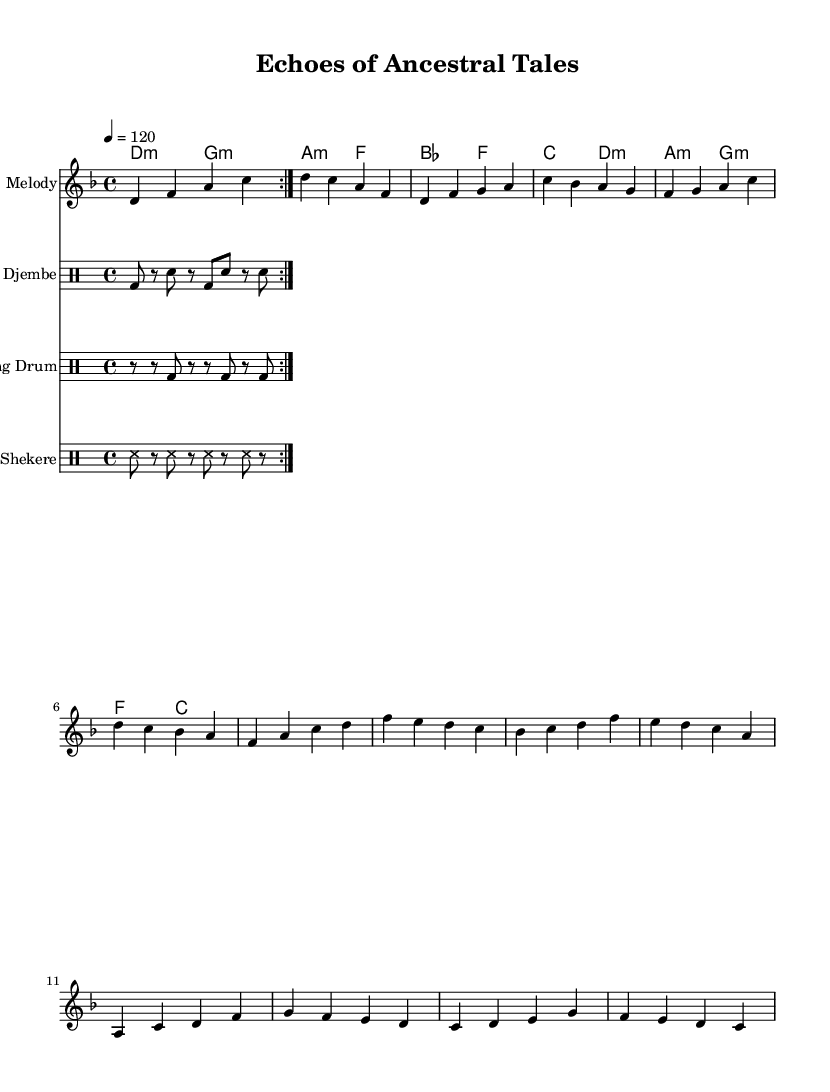What is the key signature of this music? The key signature is D minor, which contains one flat (B flat). This can be identified in the beginning of the score where the key signature is indicated.
Answer: D minor What is the time signature of this piece? The time signature is 4/4, which means there are four beats in each measure (bar) and the quarter note gets one beat. This is specified at the beginning of the score.
Answer: 4/4 What is the tempo marking for the music? The tempo marking is 120 beats per minute, which is indicated at the beginning of the score and gives the performer a guideline on how fast to play the piece.
Answer: 120 How many measures are there in the melody section? The melody section includes four distinct parts: the introduction, verse, chorus, and bridge, each typically consisting of two measures. Counting each of these sections together gives a total of ten measures for the entire melody.
Answer: 10 Which drums are used in this composition? The composition features djembe, talking drum, and shekere, as identified by the separate staff sections designated for each type in the score.
Answer: Djembe, talking drum, shekere What musical concept does the use of traditional African percussion illustrate in this piece? The use of traditional African percussion instruments reflects the fusion of cultural elements, showcasing how rhythm can enhance the storytelling aspect of the lyrics. This integration emphasizes both traditional and contemporary elements in music.
Answer: Cultural fusion 